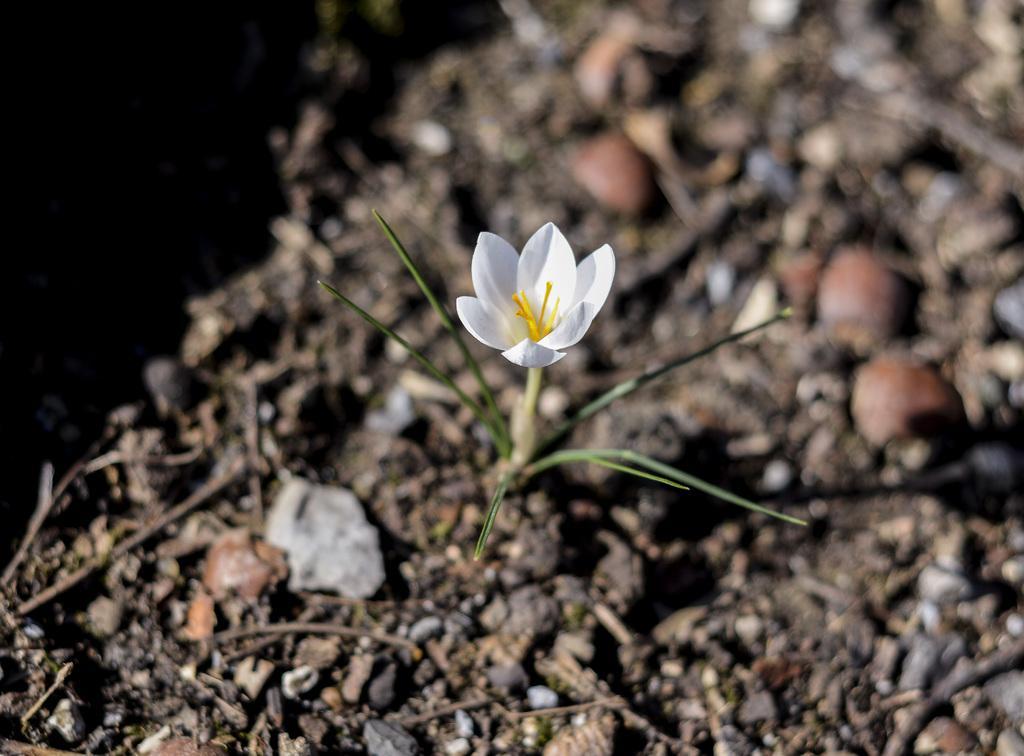Could you give a brief overview of what you see in this image? In the middle I can see a flowering plant, stones, sticks on the ground. This image is taken may be during a day. 